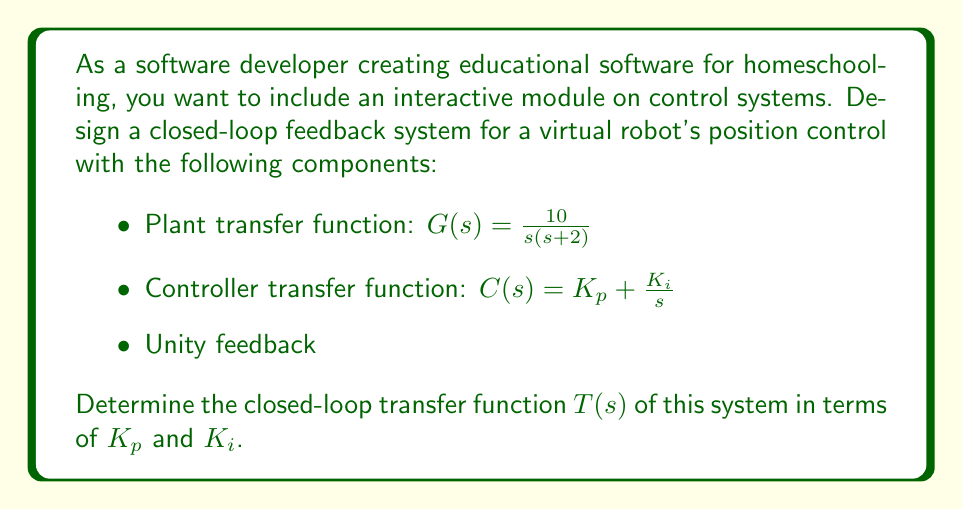Could you help me with this problem? To determine the closed-loop transfer function, we'll follow these steps:

1. Identify the open-loop transfer function:
   The open-loop transfer function is the product of the controller and plant transfer functions:
   
   $$G_{OL}(s) = C(s)G(s) = (K_p + \frac{K_i}{s}) \cdot \frac{10}{s(s+2)}$$

2. Simplify the open-loop transfer function:
   $$G_{OL}(s) = \frac{10K_p s + 10K_i}{s^2(s+2)}$$

3. Apply the closed-loop transfer function formula:
   For a unity feedback system, the closed-loop transfer function is given by:
   
   $$T(s) = \frac{G_{OL}(s)}{1 + G_{OL}(s)}$$

4. Substitute the open-loop transfer function and simplify:
   $$T(s) = \frac{\frac{10K_p s + 10K_i}{s^2(s+2)}}{1 + \frac{10K_p s + 10K_i}{s^2(s+2)}}$$

5. Find a common denominator:
   $$T(s) = \frac{10K_p s + 10K_i}{s^2(s+2) + 10K_p s + 10K_i}$$

6. Expand the denominator:
   $$T(s) = \frac{10K_p s + 10K_i}{s^3 + 2s^2 + 10K_p s + 10K_i}$$

This is the final closed-loop transfer function in terms of $K_p$ and $K_i$.
Answer: $$T(s) = \frac{10K_p s + 10K_i}{s^3 + 2s^2 + 10K_p s + 10K_i}$$ 